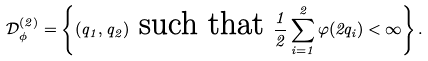Convert formula to latex. <formula><loc_0><loc_0><loc_500><loc_500>\mathcal { D } ^ { ( 2 ) } _ { \phi } = \left \{ ( q _ { 1 } , q _ { 2 } ) \text { such that } \frac { 1 } { 2 } \sum _ { i = 1 } ^ { 2 } \varphi ( 2 q _ { i } ) < \infty \right \} .</formula> 